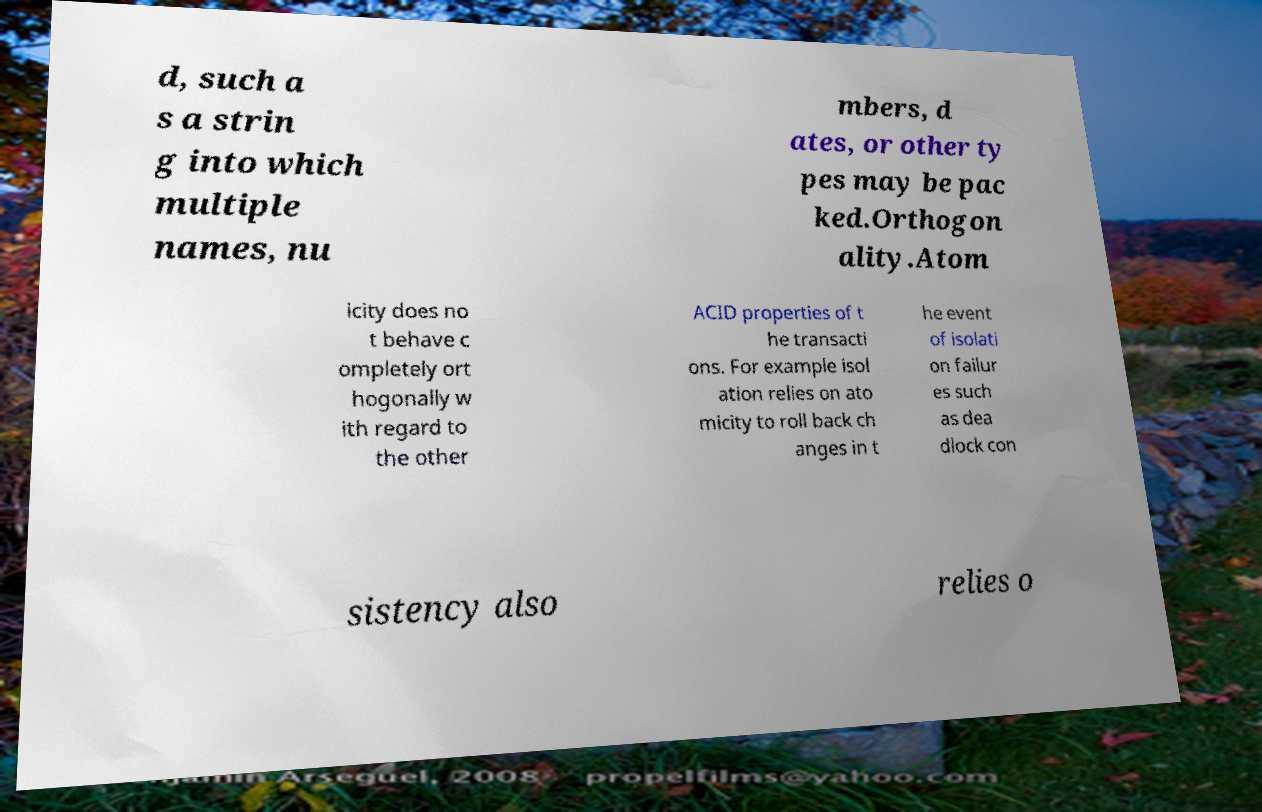Could you extract and type out the text from this image? d, such a s a strin g into which multiple names, nu mbers, d ates, or other ty pes may be pac ked.Orthogon ality.Atom icity does no t behave c ompletely ort hogonally w ith regard to the other ACID properties of t he transacti ons. For example isol ation relies on ato micity to roll back ch anges in t he event of isolati on failur es such as dea dlock con sistency also relies o 